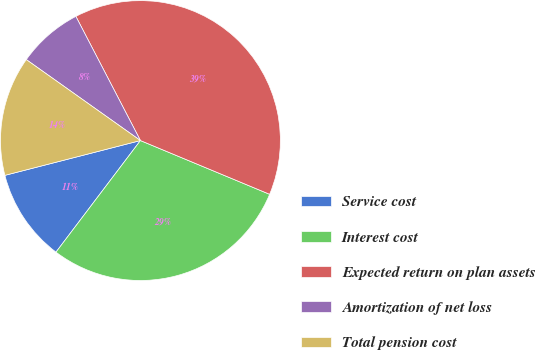Convert chart. <chart><loc_0><loc_0><loc_500><loc_500><pie_chart><fcel>Service cost<fcel>Interest cost<fcel>Expected return on plan assets<fcel>Amortization of net loss<fcel>Total pension cost<nl><fcel>10.69%<fcel>29.04%<fcel>38.91%<fcel>7.55%<fcel>13.82%<nl></chart> 